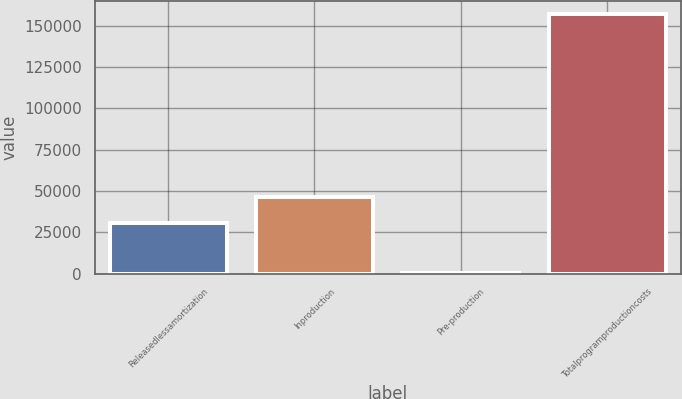<chart> <loc_0><loc_0><loc_500><loc_500><bar_chart><fcel>Releasedlessamortization<fcel>Inproduction<fcel>Pre-production<fcel>Totalprogramproductioncosts<nl><fcel>30800<fcel>46486.2<fcel>489<fcel>157351<nl></chart> 